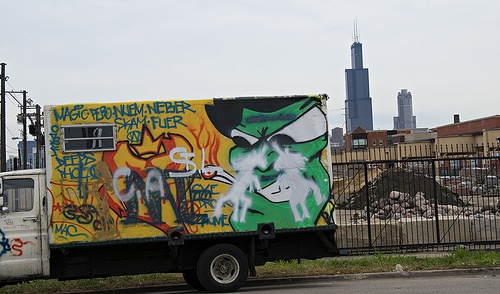Describe the objects in this image and their specific colors. I can see a truck in lightgray, black, darkgray, olive, and gray tones in this image. 